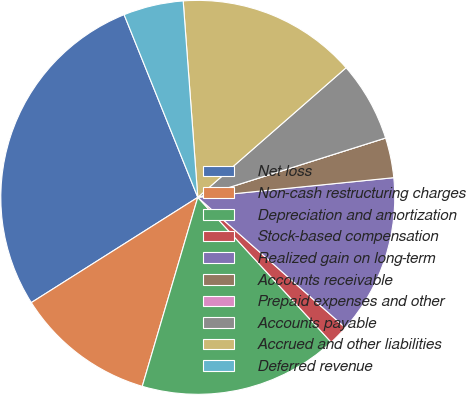Convert chart. <chart><loc_0><loc_0><loc_500><loc_500><pie_chart><fcel>Net loss<fcel>Non-cash restructuring charges<fcel>Depreciation and amortization<fcel>Stock-based compensation<fcel>Realized gain on long-term<fcel>Accounts receivable<fcel>Prepaid expenses and other<fcel>Accounts payable<fcel>Accrued and other liabilities<fcel>Deferred revenue<nl><fcel>27.87%<fcel>11.48%<fcel>16.39%<fcel>1.64%<fcel>13.11%<fcel>3.28%<fcel>0.0%<fcel>6.56%<fcel>14.75%<fcel>4.92%<nl></chart> 